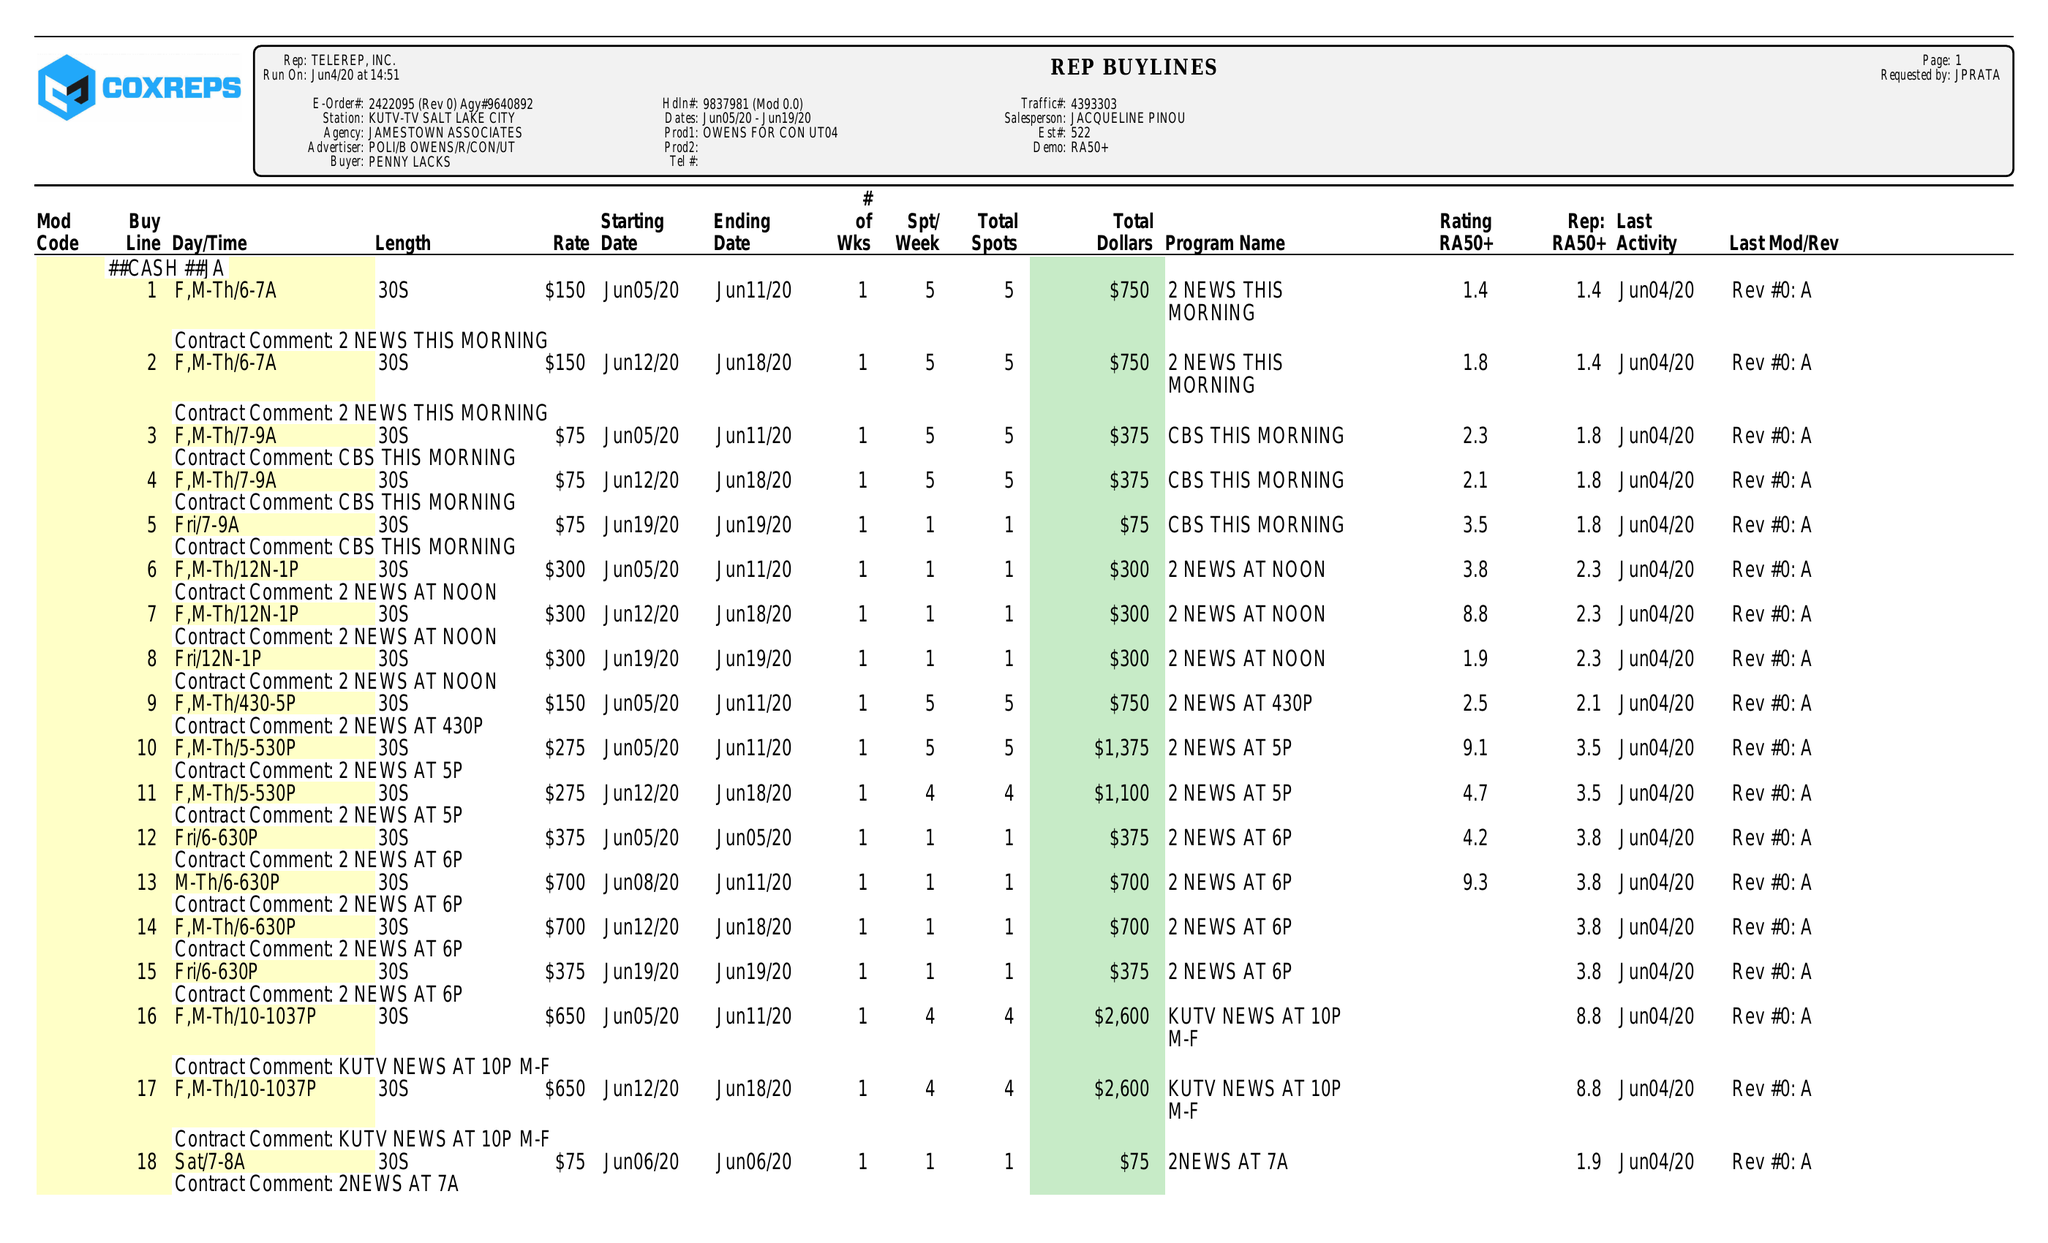What is the value for the contract_num?
Answer the question using a single word or phrase. 2422095 